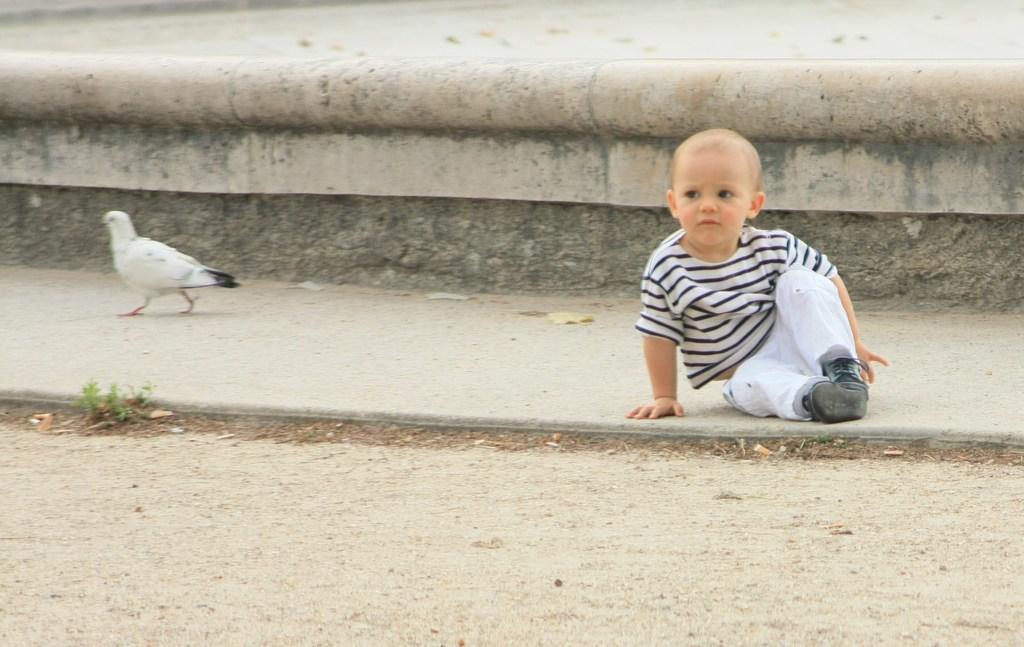Can you describe this image briefly? In this image I can see the child sitting on the road. The child is wearing the black and white color dress. To the left I can see the bird which is in white and black color. I can also see the grass. 